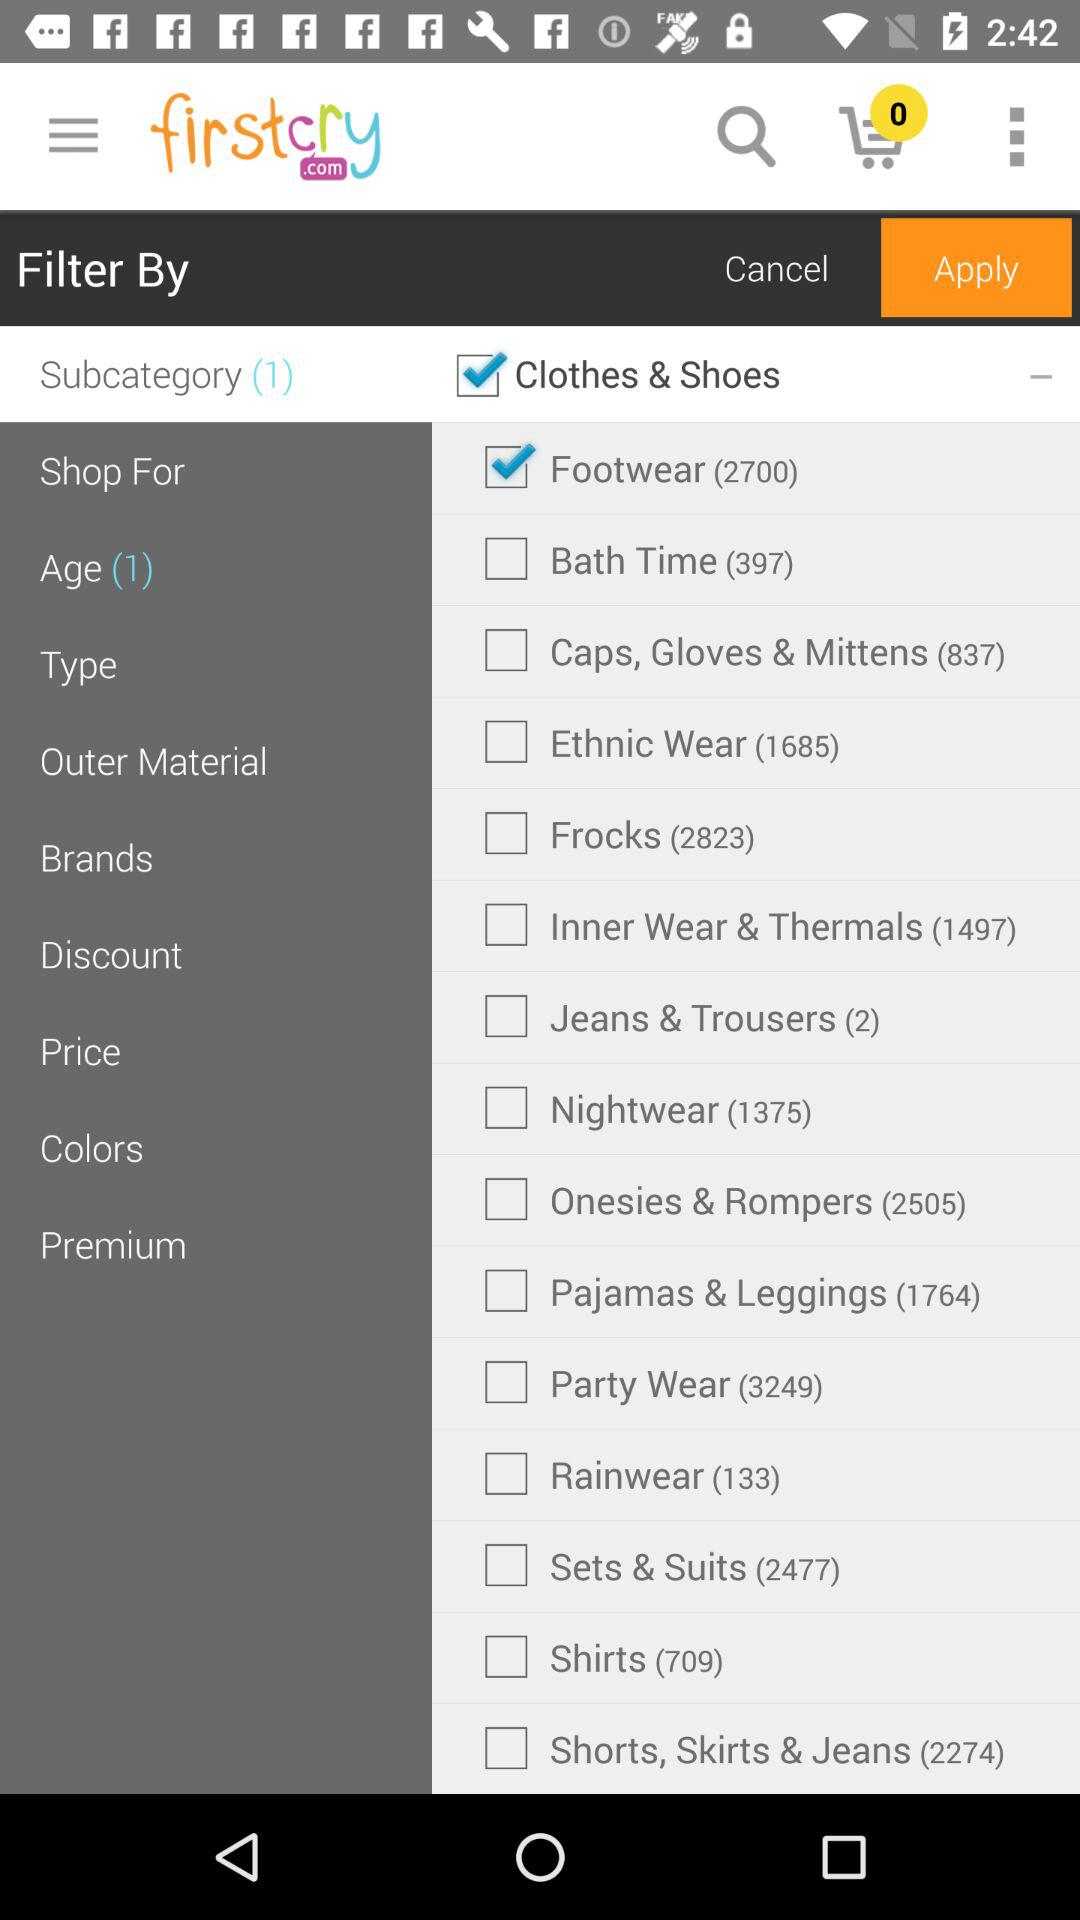How many ethnic wears are there? There are 1685 ethnic wears. 